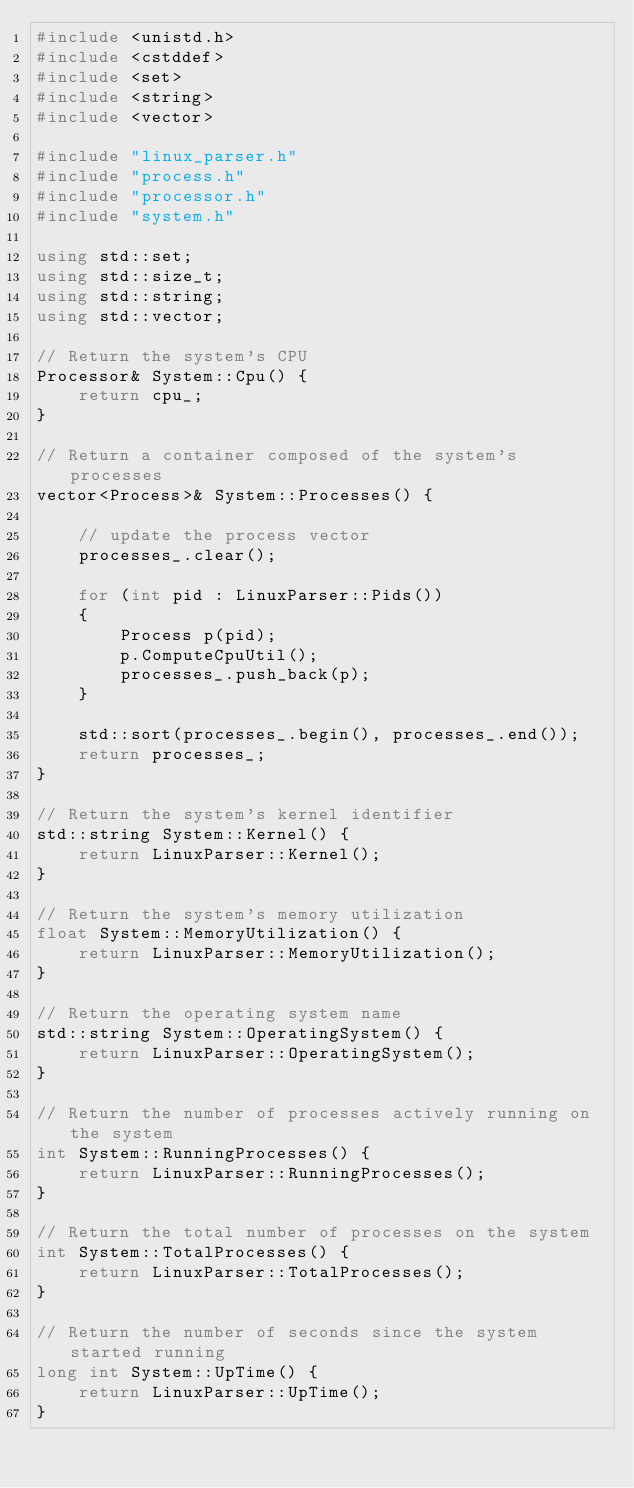<code> <loc_0><loc_0><loc_500><loc_500><_C++_>#include <unistd.h>
#include <cstddef>
#include <set>
#include <string>
#include <vector>

#include "linux_parser.h"
#include "process.h"
#include "processor.h"
#include "system.h"

using std::set;
using std::size_t;
using std::string;
using std::vector;

// Return the system's CPU
Processor& System::Cpu() {
    return cpu_;
}

// Return a container composed of the system's processes
vector<Process>& System::Processes() {
  
  	// update the process vector
    processes_.clear();

    for (int pid : LinuxParser::Pids())
    {
        Process p(pid);
        p.ComputeCpuUtil();
        processes_.push_back(p);
    }

    std::sort(processes_.begin(), processes_.end());
    return processes_;
}

// Return the system's kernel identifier
std::string System::Kernel() {
    return LinuxParser::Kernel();
}

// Return the system's memory utilization
float System::MemoryUtilization() {
    return LinuxParser::MemoryUtilization();
}

// Return the operating system name
std::string System::OperatingSystem() {
    return LinuxParser::OperatingSystem();
}

// Return the number of processes actively running on the system
int System::RunningProcesses() {
    return LinuxParser::RunningProcesses();
}

// Return the total number of processes on the system
int System::TotalProcesses() {
    return LinuxParser::TotalProcesses();
}

// Return the number of seconds since the system started running
long int System::UpTime() {
    return LinuxParser::UpTime();
}</code> 